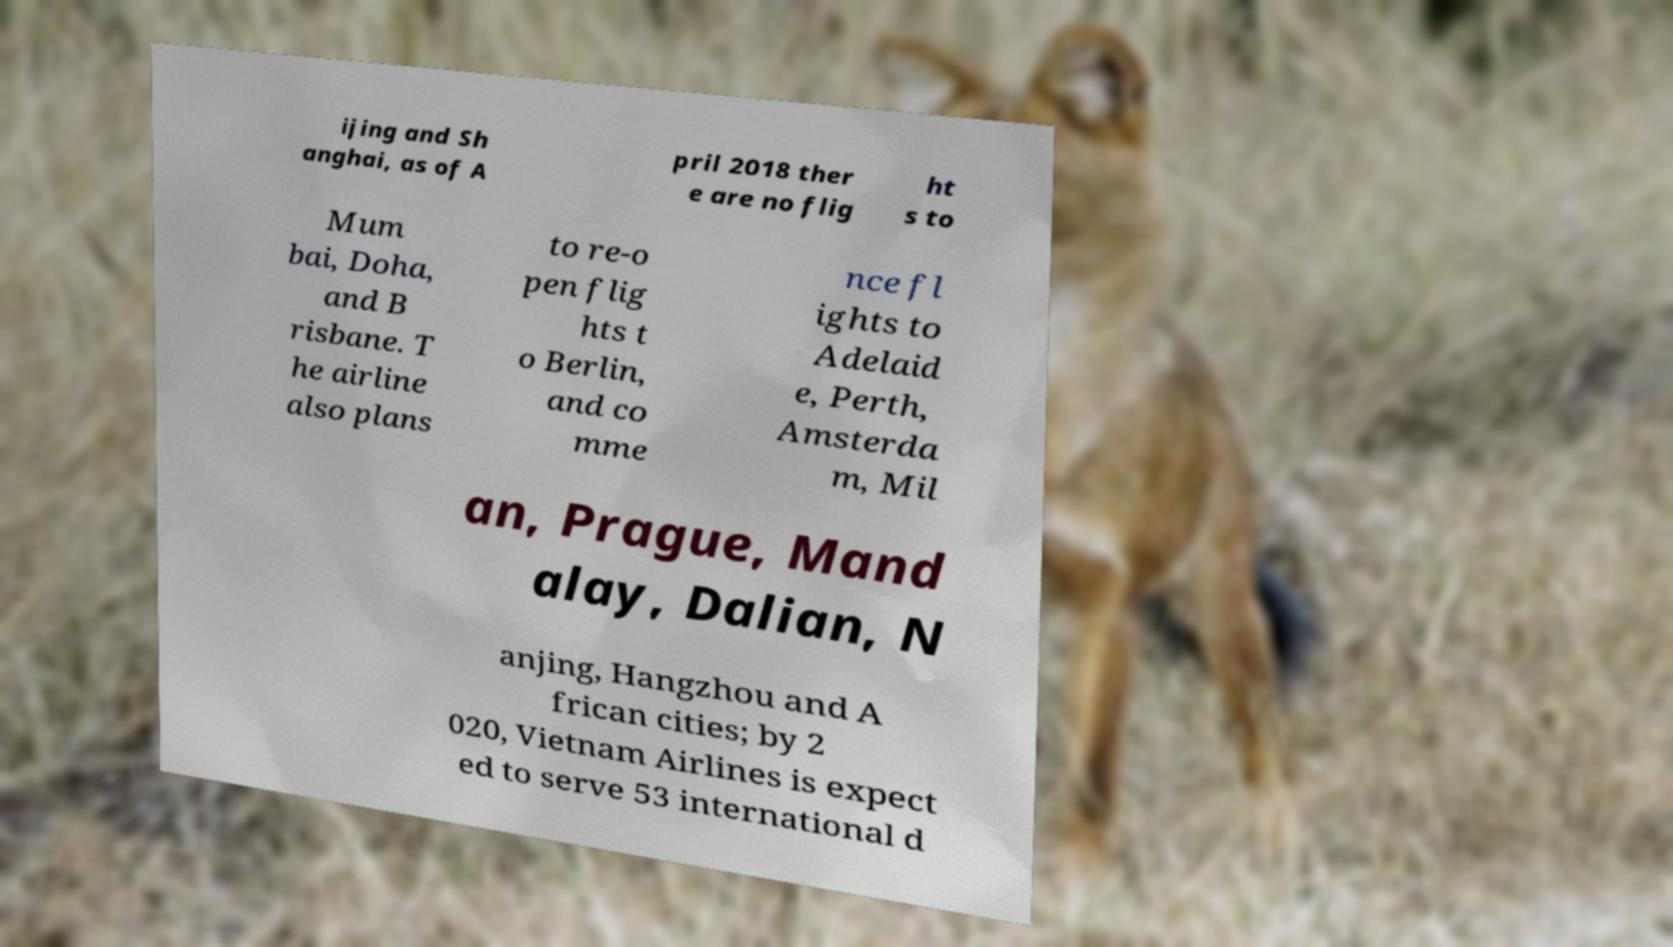Can you accurately transcribe the text from the provided image for me? ijing and Sh anghai, as of A pril 2018 ther e are no flig ht s to Mum bai, Doha, and B risbane. T he airline also plans to re-o pen flig hts t o Berlin, and co mme nce fl ights to Adelaid e, Perth, Amsterda m, Mil an, Prague, Mand alay, Dalian, N anjing, Hangzhou and A frican cities; by 2 020, Vietnam Airlines is expect ed to serve 53 international d 